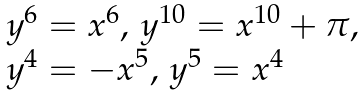<formula> <loc_0><loc_0><loc_500><loc_500>\begin{array} { l } y ^ { 6 } = x ^ { 6 } , \, y ^ { 1 0 } = x ^ { 1 0 } + \pi , \\ y ^ { 4 } = - x ^ { 5 } , \, y ^ { 5 } = x ^ { 4 } \end{array}</formula> 